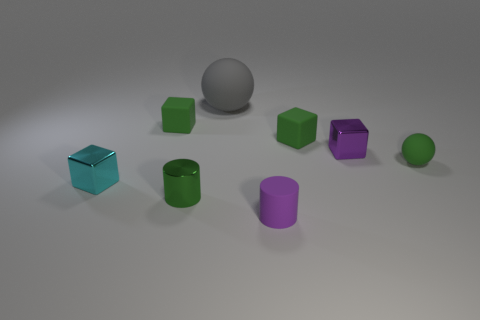Do the tiny purple matte object and the big object have the same shape?
Keep it short and to the point. No. How many gray metal cylinders are the same size as the purple metal cube?
Offer a very short reply. 0. Are there fewer spheres that are to the left of the small green cylinder than big gray matte objects?
Your response must be concise. Yes. How big is the gray rubber thing behind the purple object in front of the cyan thing?
Make the answer very short. Large. What number of things are tiny cyan metallic things or large green cylinders?
Your answer should be very brief. 1. Are there any large shiny cubes that have the same color as the large thing?
Offer a terse response. No. Is the number of purple rubber things less than the number of red blocks?
Provide a succinct answer. No. How many objects are purple metal objects or green things right of the small purple metal cube?
Offer a terse response. 2. Are there any tiny brown cylinders that have the same material as the green cylinder?
Your answer should be compact. No. There is another cylinder that is the same size as the green metal cylinder; what is it made of?
Ensure brevity in your answer.  Rubber. 